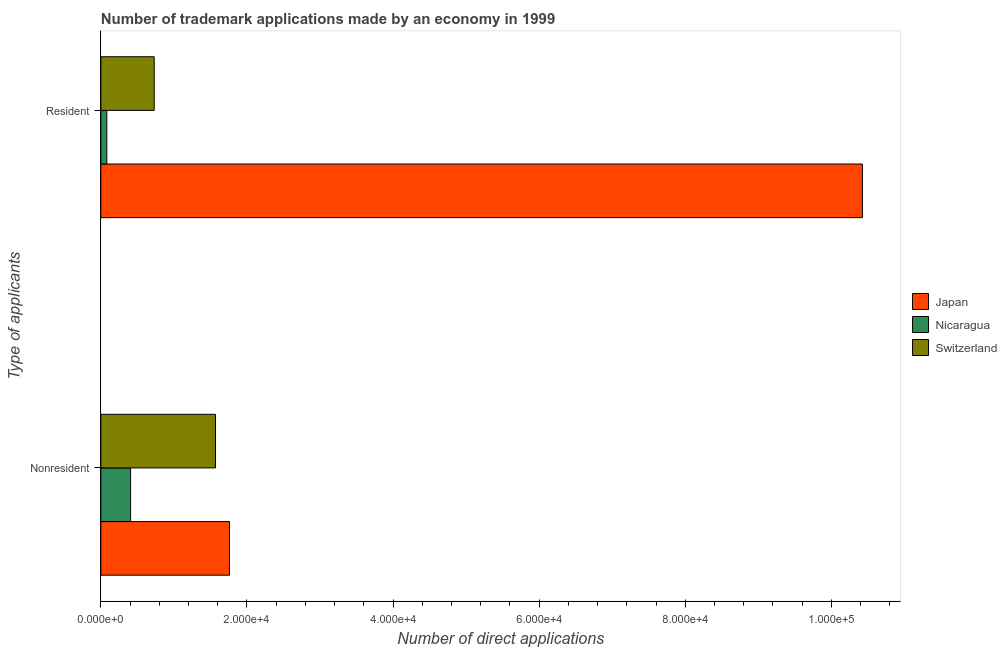How many different coloured bars are there?
Your response must be concise. 3. How many groups of bars are there?
Your response must be concise. 2. Are the number of bars per tick equal to the number of legend labels?
Ensure brevity in your answer.  Yes. Are the number of bars on each tick of the Y-axis equal?
Your answer should be compact. Yes. How many bars are there on the 2nd tick from the top?
Make the answer very short. 3. How many bars are there on the 2nd tick from the bottom?
Offer a very short reply. 3. What is the label of the 1st group of bars from the top?
Give a very brief answer. Resident. What is the number of trademark applications made by non residents in Japan?
Make the answer very short. 1.76e+04. Across all countries, what is the maximum number of trademark applications made by residents?
Make the answer very short. 1.04e+05. Across all countries, what is the minimum number of trademark applications made by residents?
Offer a terse response. 820. In which country was the number of trademark applications made by residents minimum?
Offer a very short reply. Nicaragua. What is the total number of trademark applications made by residents in the graph?
Provide a short and direct response. 1.12e+05. What is the difference between the number of trademark applications made by residents in Nicaragua and that in Switzerland?
Your response must be concise. -6487. What is the difference between the number of trademark applications made by residents in Nicaragua and the number of trademark applications made by non residents in Japan?
Give a very brief answer. -1.68e+04. What is the average number of trademark applications made by non residents per country?
Provide a short and direct response. 1.25e+04. What is the difference between the number of trademark applications made by residents and number of trademark applications made by non residents in Japan?
Keep it short and to the point. 8.66e+04. What is the ratio of the number of trademark applications made by non residents in Nicaragua to that in Switzerland?
Keep it short and to the point. 0.26. Is the number of trademark applications made by non residents in Japan less than that in Switzerland?
Provide a short and direct response. No. In how many countries, is the number of trademark applications made by residents greater than the average number of trademark applications made by residents taken over all countries?
Provide a succinct answer. 1. What does the 3rd bar from the top in Nonresident represents?
Offer a terse response. Japan. What does the 3rd bar from the bottom in Resident represents?
Provide a succinct answer. Switzerland. How many bars are there?
Give a very brief answer. 6. How many countries are there in the graph?
Provide a short and direct response. 3. Are the values on the major ticks of X-axis written in scientific E-notation?
Give a very brief answer. Yes. Does the graph contain grids?
Offer a very short reply. No. What is the title of the graph?
Your response must be concise. Number of trademark applications made by an economy in 1999. Does "Suriname" appear as one of the legend labels in the graph?
Provide a short and direct response. No. What is the label or title of the X-axis?
Keep it short and to the point. Number of direct applications. What is the label or title of the Y-axis?
Your answer should be very brief. Type of applicants. What is the Number of direct applications of Japan in Nonresident?
Your answer should be very brief. 1.76e+04. What is the Number of direct applications of Nicaragua in Nonresident?
Give a very brief answer. 4072. What is the Number of direct applications in Switzerland in Nonresident?
Offer a very short reply. 1.57e+04. What is the Number of direct applications of Japan in Resident?
Your response must be concise. 1.04e+05. What is the Number of direct applications of Nicaragua in Resident?
Offer a very short reply. 820. What is the Number of direct applications in Switzerland in Resident?
Keep it short and to the point. 7307. Across all Type of applicants, what is the maximum Number of direct applications of Japan?
Provide a succinct answer. 1.04e+05. Across all Type of applicants, what is the maximum Number of direct applications of Nicaragua?
Your answer should be very brief. 4072. Across all Type of applicants, what is the maximum Number of direct applications of Switzerland?
Offer a very short reply. 1.57e+04. Across all Type of applicants, what is the minimum Number of direct applications of Japan?
Your answer should be very brief. 1.76e+04. Across all Type of applicants, what is the minimum Number of direct applications of Nicaragua?
Offer a terse response. 820. Across all Type of applicants, what is the minimum Number of direct applications in Switzerland?
Provide a succinct answer. 7307. What is the total Number of direct applications in Japan in the graph?
Provide a short and direct response. 1.22e+05. What is the total Number of direct applications in Nicaragua in the graph?
Your response must be concise. 4892. What is the total Number of direct applications in Switzerland in the graph?
Keep it short and to the point. 2.30e+04. What is the difference between the Number of direct applications in Japan in Nonresident and that in Resident?
Provide a succinct answer. -8.66e+04. What is the difference between the Number of direct applications in Nicaragua in Nonresident and that in Resident?
Your answer should be very brief. 3252. What is the difference between the Number of direct applications in Switzerland in Nonresident and that in Resident?
Your response must be concise. 8384. What is the difference between the Number of direct applications of Japan in Nonresident and the Number of direct applications of Nicaragua in Resident?
Make the answer very short. 1.68e+04. What is the difference between the Number of direct applications in Japan in Nonresident and the Number of direct applications in Switzerland in Resident?
Offer a very short reply. 1.03e+04. What is the difference between the Number of direct applications of Nicaragua in Nonresident and the Number of direct applications of Switzerland in Resident?
Your answer should be very brief. -3235. What is the average Number of direct applications of Japan per Type of applicants?
Offer a terse response. 6.09e+04. What is the average Number of direct applications of Nicaragua per Type of applicants?
Keep it short and to the point. 2446. What is the average Number of direct applications in Switzerland per Type of applicants?
Give a very brief answer. 1.15e+04. What is the difference between the Number of direct applications in Japan and Number of direct applications in Nicaragua in Nonresident?
Offer a terse response. 1.35e+04. What is the difference between the Number of direct applications of Japan and Number of direct applications of Switzerland in Nonresident?
Make the answer very short. 1918. What is the difference between the Number of direct applications in Nicaragua and Number of direct applications in Switzerland in Nonresident?
Give a very brief answer. -1.16e+04. What is the difference between the Number of direct applications in Japan and Number of direct applications in Nicaragua in Resident?
Ensure brevity in your answer.  1.03e+05. What is the difference between the Number of direct applications in Japan and Number of direct applications in Switzerland in Resident?
Provide a succinct answer. 9.69e+04. What is the difference between the Number of direct applications in Nicaragua and Number of direct applications in Switzerland in Resident?
Keep it short and to the point. -6487. What is the ratio of the Number of direct applications in Japan in Nonresident to that in Resident?
Provide a succinct answer. 0.17. What is the ratio of the Number of direct applications of Nicaragua in Nonresident to that in Resident?
Keep it short and to the point. 4.97. What is the ratio of the Number of direct applications of Switzerland in Nonresident to that in Resident?
Ensure brevity in your answer.  2.15. What is the difference between the highest and the second highest Number of direct applications of Japan?
Your answer should be very brief. 8.66e+04. What is the difference between the highest and the second highest Number of direct applications of Nicaragua?
Provide a short and direct response. 3252. What is the difference between the highest and the second highest Number of direct applications of Switzerland?
Offer a very short reply. 8384. What is the difference between the highest and the lowest Number of direct applications of Japan?
Provide a succinct answer. 8.66e+04. What is the difference between the highest and the lowest Number of direct applications in Nicaragua?
Keep it short and to the point. 3252. What is the difference between the highest and the lowest Number of direct applications in Switzerland?
Make the answer very short. 8384. 